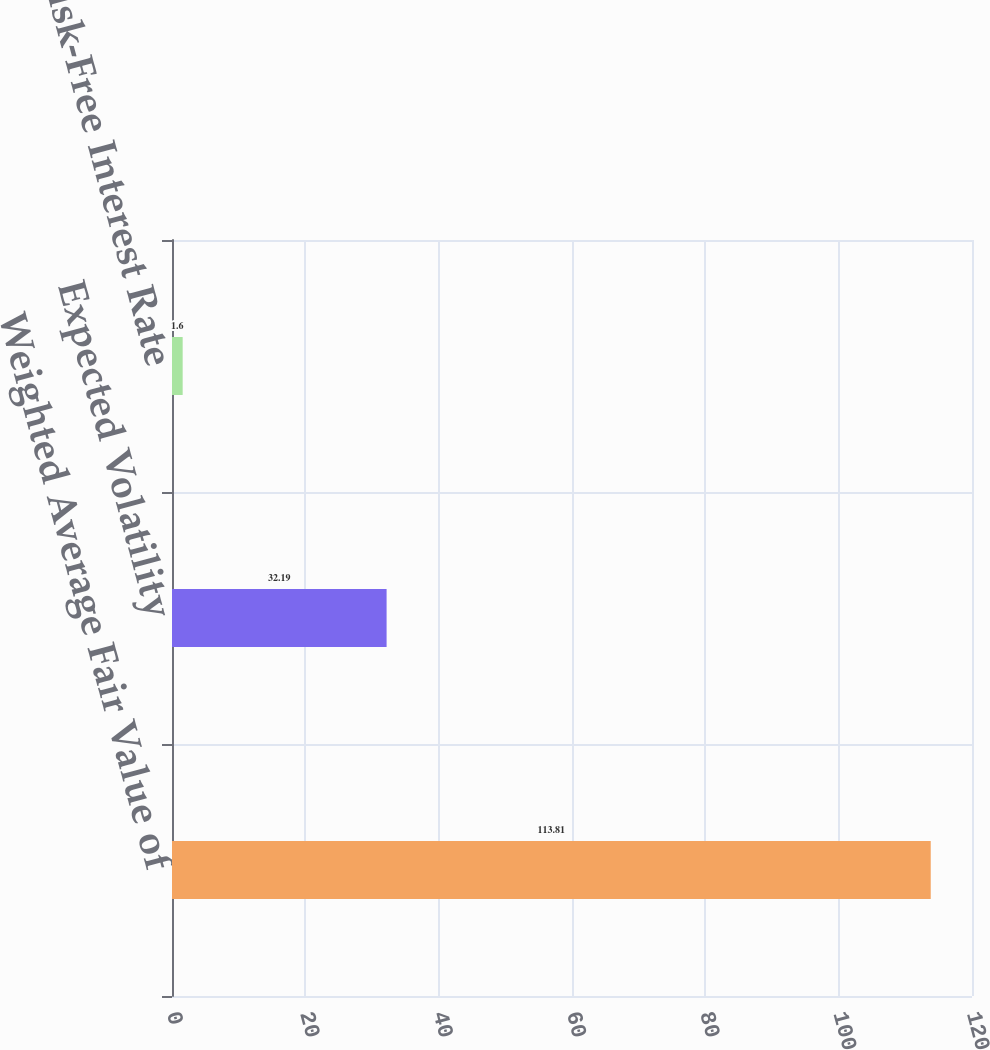<chart> <loc_0><loc_0><loc_500><loc_500><bar_chart><fcel>Weighted Average Fair Value of<fcel>Expected Volatility<fcel>Risk-Free Interest Rate<nl><fcel>113.81<fcel>32.19<fcel>1.6<nl></chart> 